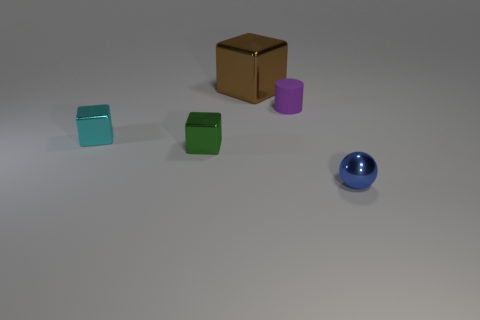Subtract all tiny cubes. How many cubes are left? 1 Add 2 purple cylinders. How many objects exist? 7 Subtract 1 cylinders. How many cylinders are left? 0 Subtract all cubes. How many objects are left? 2 Add 5 rubber things. How many rubber things are left? 6 Add 4 green blocks. How many green blocks exist? 5 Subtract all brown blocks. How many blocks are left? 2 Subtract 0 green spheres. How many objects are left? 5 Subtract all yellow cylinders. Subtract all blue spheres. How many cylinders are left? 1 Subtract all blue spheres. How many cyan cubes are left? 1 